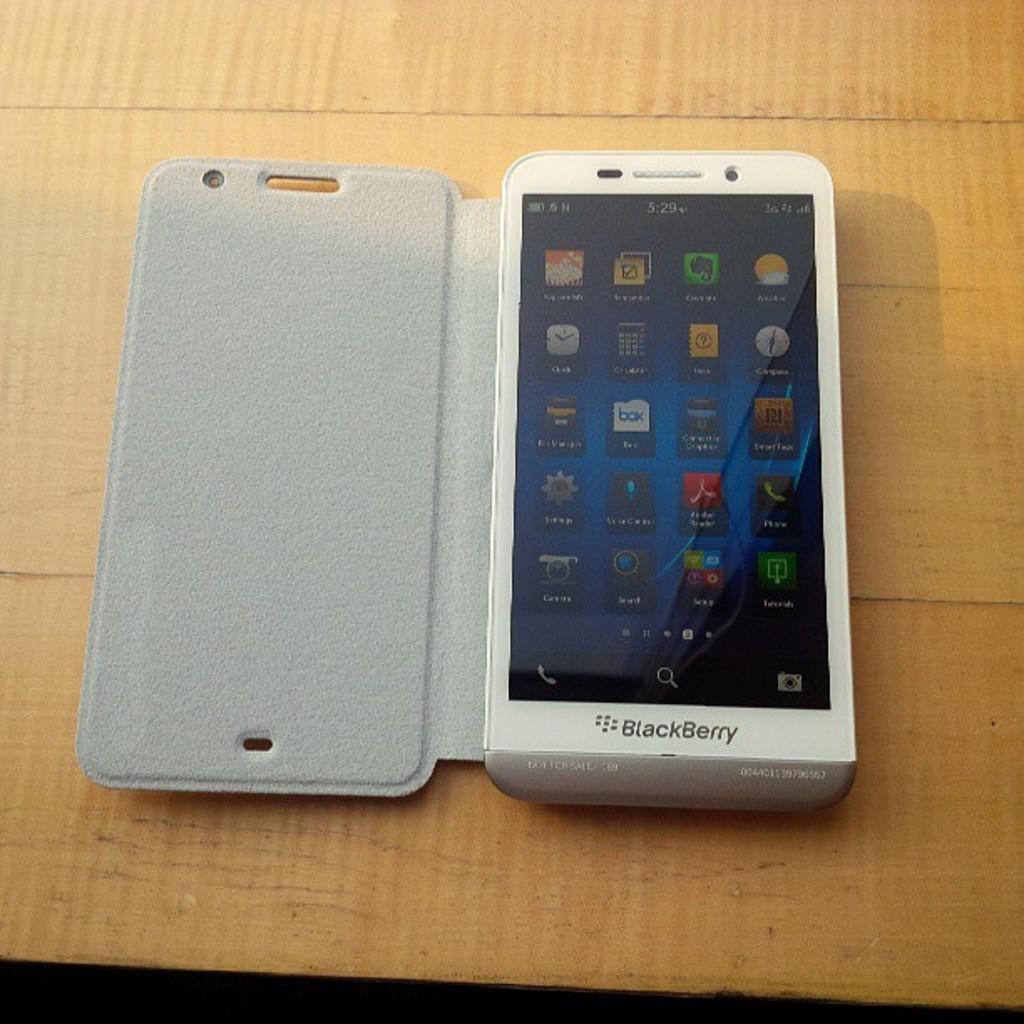What is the brand of this phone?
Offer a terse response. Blackberry. Who makes this phone?
Your response must be concise. Blackberry. 